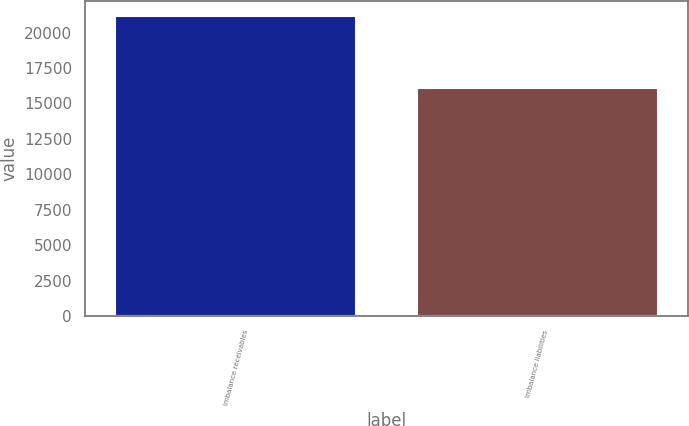<chart> <loc_0><loc_0><loc_500><loc_500><bar_chart><fcel>Imbalance receivables<fcel>Imbalance liabilities<nl><fcel>21200<fcel>16100<nl></chart> 